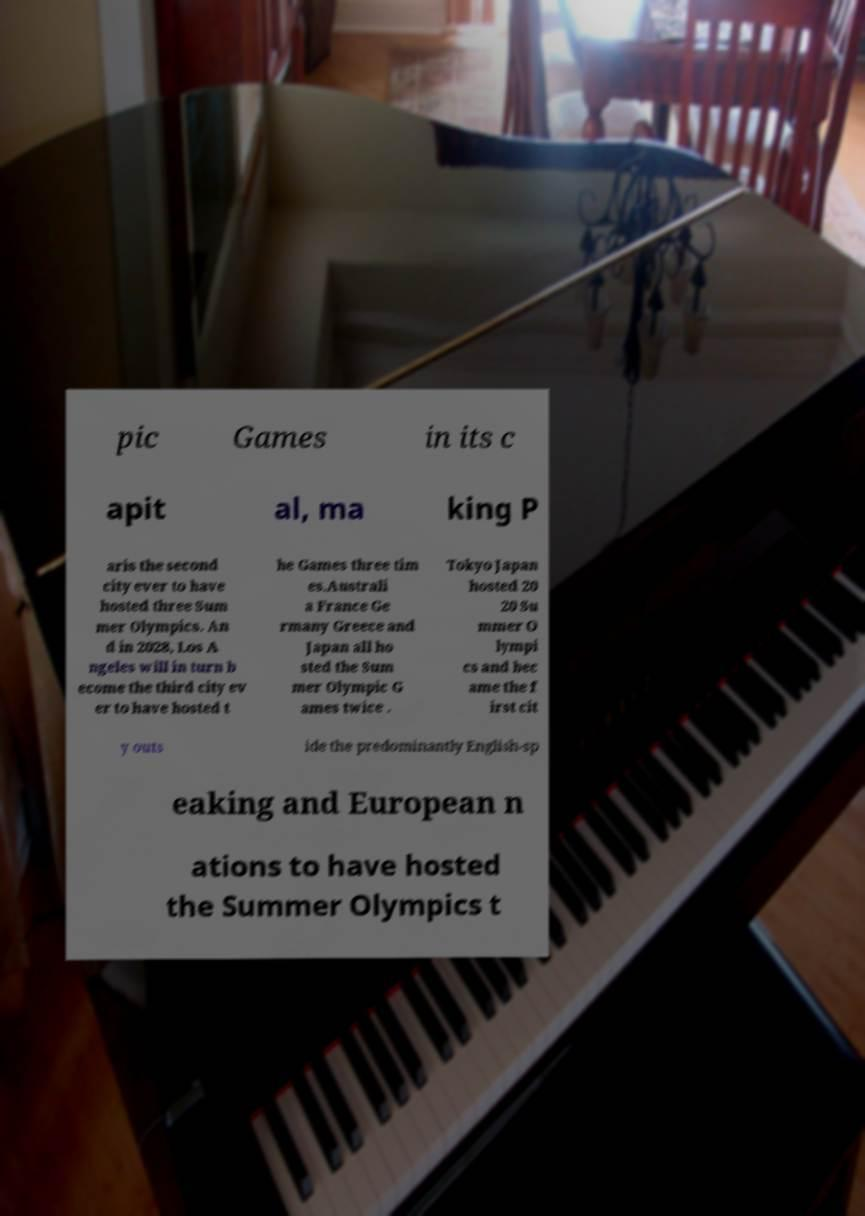Could you assist in decoding the text presented in this image and type it out clearly? pic Games in its c apit al, ma king P aris the second city ever to have hosted three Sum mer Olympics. An d in 2028, Los A ngeles will in turn b ecome the third city ev er to have hosted t he Games three tim es.Australi a France Ge rmany Greece and Japan all ho sted the Sum mer Olympic G ames twice . Tokyo Japan hosted 20 20 Su mmer O lympi cs and bec ame the f irst cit y outs ide the predominantly English-sp eaking and European n ations to have hosted the Summer Olympics t 